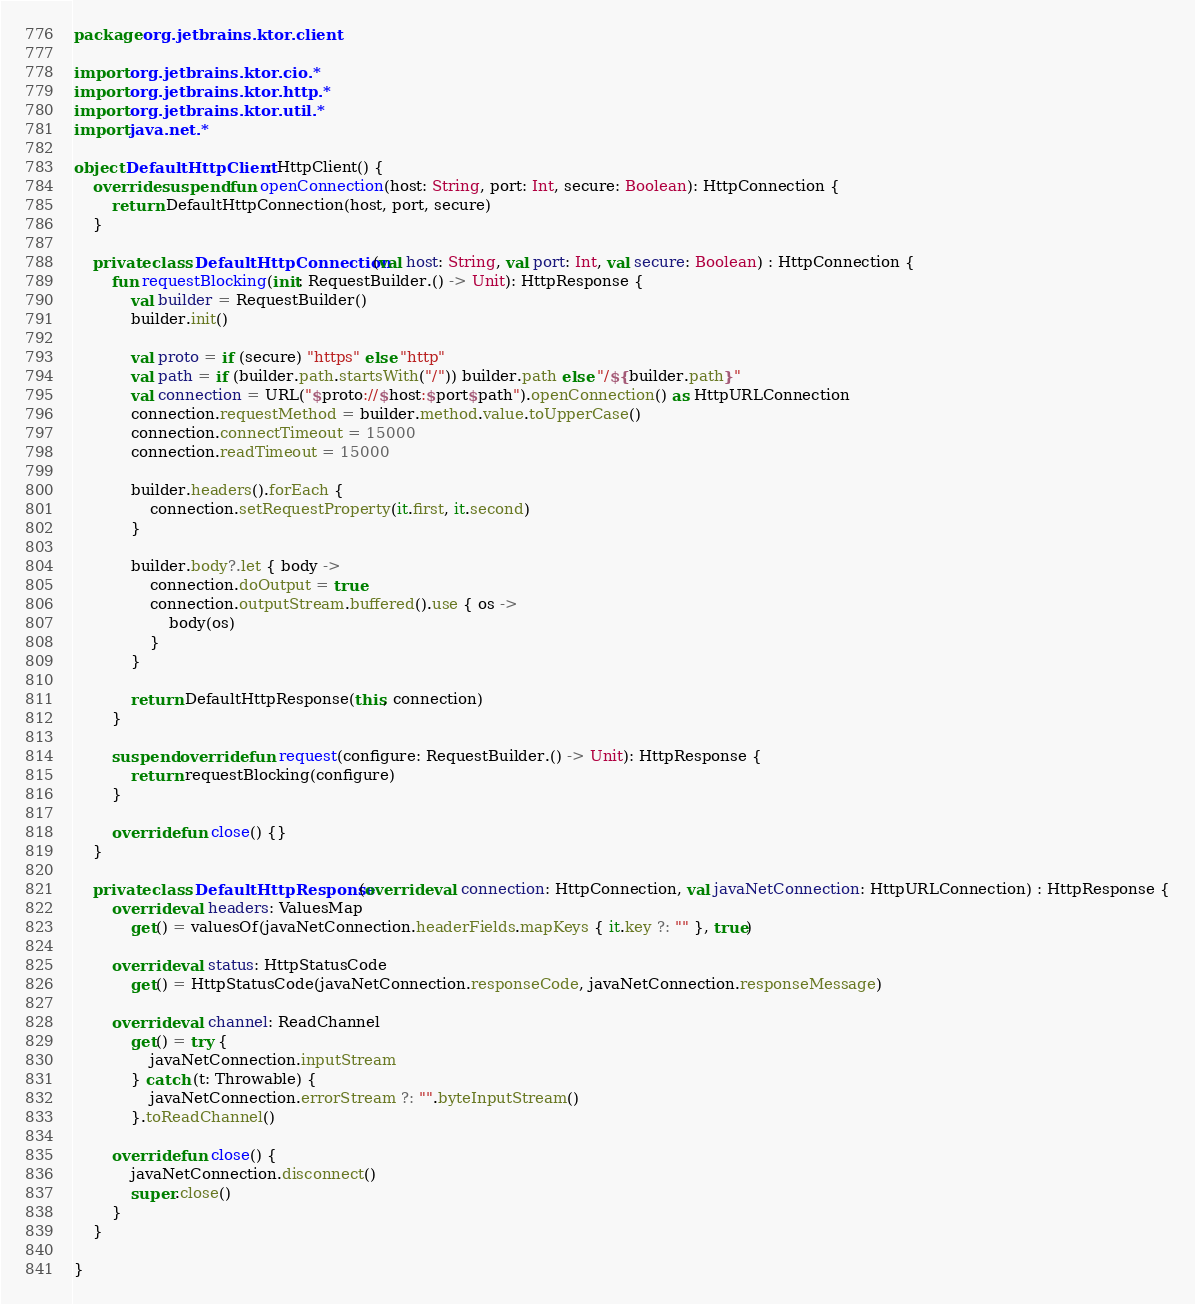<code> <loc_0><loc_0><loc_500><loc_500><_Kotlin_>package org.jetbrains.ktor.client

import org.jetbrains.ktor.cio.*
import org.jetbrains.ktor.http.*
import org.jetbrains.ktor.util.*
import java.net.*

object DefaultHttpClient : HttpClient() {
    override suspend fun openConnection(host: String, port: Int, secure: Boolean): HttpConnection {
        return DefaultHttpConnection(host, port, secure)
    }

    private class DefaultHttpConnection(val host: String, val port: Int, val secure: Boolean) : HttpConnection {
        fun requestBlocking(init: RequestBuilder.() -> Unit): HttpResponse {
            val builder = RequestBuilder()
            builder.init()

            val proto = if (secure) "https" else "http"
            val path = if (builder.path.startsWith("/")) builder.path else "/${builder.path}"
            val connection = URL("$proto://$host:$port$path").openConnection() as HttpURLConnection
            connection.requestMethod = builder.method.value.toUpperCase()
            connection.connectTimeout = 15000
            connection.readTimeout = 15000

            builder.headers().forEach {
                connection.setRequestProperty(it.first, it.second)
            }

            builder.body?.let { body ->
                connection.doOutput = true
                connection.outputStream.buffered().use { os ->
                    body(os)
                }
            }

            return DefaultHttpResponse(this, connection)
        }

        suspend override fun request(configure: RequestBuilder.() -> Unit): HttpResponse {
            return requestBlocking(configure)
        }

        override fun close() {}
    }

    private class DefaultHttpResponse(override val connection: HttpConnection, val javaNetConnection: HttpURLConnection) : HttpResponse {
        override val headers: ValuesMap
            get() = valuesOf(javaNetConnection.headerFields.mapKeys { it.key ?: "" }, true)

        override val status: HttpStatusCode
            get() = HttpStatusCode(javaNetConnection.responseCode, javaNetConnection.responseMessage)

        override val channel: ReadChannel
            get() = try {
                javaNetConnection.inputStream
            } catch (t: Throwable) {
                javaNetConnection.errorStream ?: "".byteInputStream()
            }.toReadChannel()

        override fun close() {
            javaNetConnection.disconnect()
            super.close()
        }
    }

}
</code> 